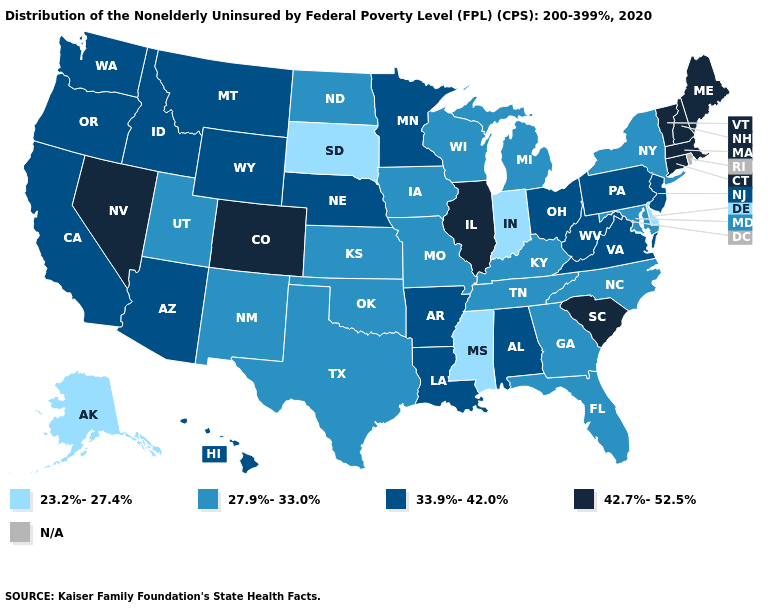Name the states that have a value in the range 42.7%-52.5%?
Quick response, please. Colorado, Connecticut, Illinois, Maine, Massachusetts, Nevada, New Hampshire, South Carolina, Vermont. What is the value of Alaska?
Answer briefly. 23.2%-27.4%. Which states have the highest value in the USA?
Keep it brief. Colorado, Connecticut, Illinois, Maine, Massachusetts, Nevada, New Hampshire, South Carolina, Vermont. How many symbols are there in the legend?
Write a very short answer. 5. What is the lowest value in states that border Maine?
Keep it brief. 42.7%-52.5%. Name the states that have a value in the range 42.7%-52.5%?
Concise answer only. Colorado, Connecticut, Illinois, Maine, Massachusetts, Nevada, New Hampshire, South Carolina, Vermont. What is the value of Michigan?
Be succinct. 27.9%-33.0%. What is the value of Arkansas?
Keep it brief. 33.9%-42.0%. How many symbols are there in the legend?
Concise answer only. 5. Name the states that have a value in the range 42.7%-52.5%?
Short answer required. Colorado, Connecticut, Illinois, Maine, Massachusetts, Nevada, New Hampshire, South Carolina, Vermont. Which states have the lowest value in the MidWest?
Write a very short answer. Indiana, South Dakota. Is the legend a continuous bar?
Answer briefly. No. Among the states that border Indiana , does Illinois have the highest value?
Be succinct. Yes. Name the states that have a value in the range N/A?
Quick response, please. Rhode Island. What is the value of New Jersey?
Be succinct. 33.9%-42.0%. 